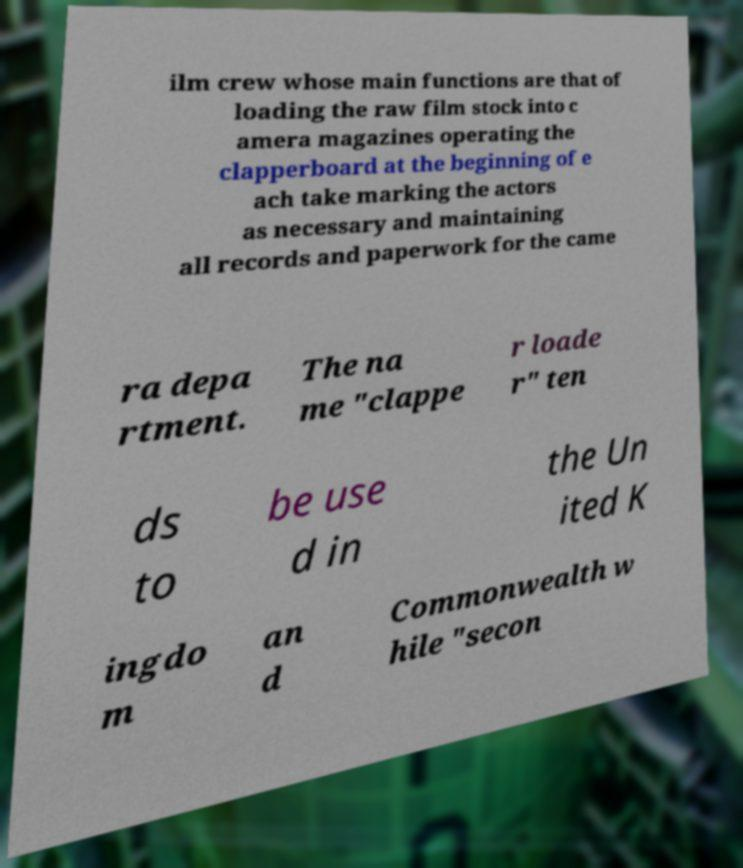There's text embedded in this image that I need extracted. Can you transcribe it verbatim? ilm crew whose main functions are that of loading the raw film stock into c amera magazines operating the clapperboard at the beginning of e ach take marking the actors as necessary and maintaining all records and paperwork for the came ra depa rtment. The na me "clappe r loade r" ten ds to be use d in the Un ited K ingdo m an d Commonwealth w hile "secon 